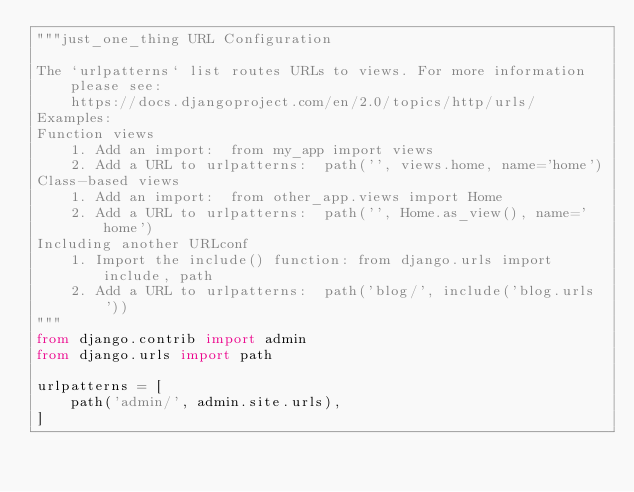<code> <loc_0><loc_0><loc_500><loc_500><_Python_>"""just_one_thing URL Configuration

The `urlpatterns` list routes URLs to views. For more information please see:
    https://docs.djangoproject.com/en/2.0/topics/http/urls/
Examples:
Function views
    1. Add an import:  from my_app import views
    2. Add a URL to urlpatterns:  path('', views.home, name='home')
Class-based views
    1. Add an import:  from other_app.views import Home
    2. Add a URL to urlpatterns:  path('', Home.as_view(), name='home')
Including another URLconf
    1. Import the include() function: from django.urls import include, path
    2. Add a URL to urlpatterns:  path('blog/', include('blog.urls'))
"""
from django.contrib import admin
from django.urls import path

urlpatterns = [
    path('admin/', admin.site.urls),
]
</code> 